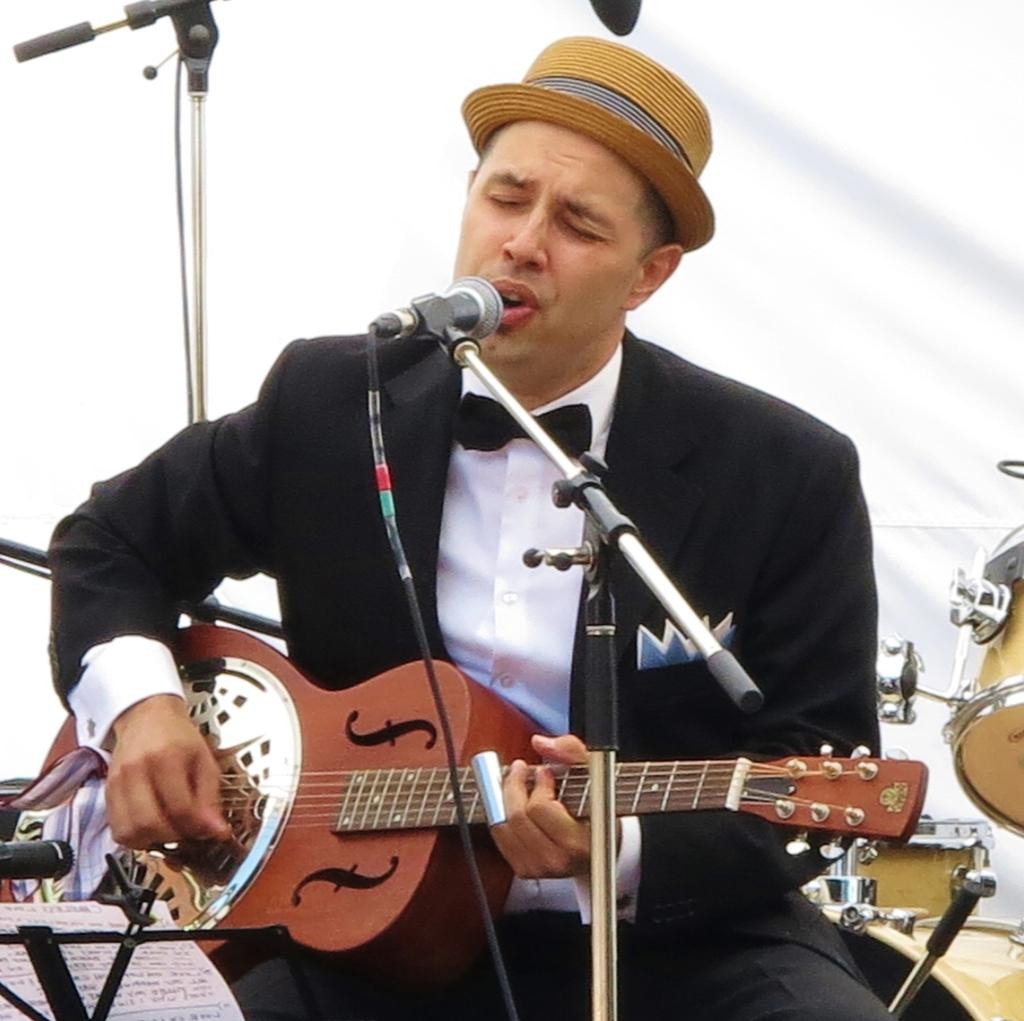What is the person in the image doing? The person is holding a guitar and has their mouth open. What object is in front of the person? There is a microphone in front of the person. What might the person be about to do? The person might be about to sing or play the guitar. Can you see any islands in the image? No, there are no islands present in the image. What type of jelly is being used as a guitar pick in the image? There is no jelly or guitar pick visible in the image. 